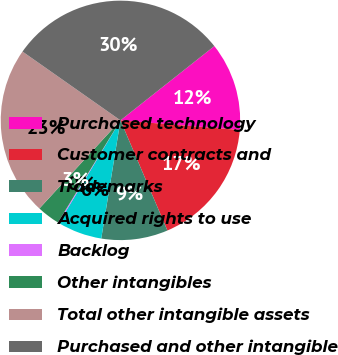Convert chart. <chart><loc_0><loc_0><loc_500><loc_500><pie_chart><fcel>Purchased technology<fcel>Customer contracts and<fcel>Trademarks<fcel>Acquired rights to use<fcel>Backlog<fcel>Other intangibles<fcel>Total other intangible assets<fcel>Purchased and other intangible<nl><fcel>11.93%<fcel>17.31%<fcel>8.98%<fcel>6.04%<fcel>0.14%<fcel>3.09%<fcel>22.91%<fcel>29.6%<nl></chart> 